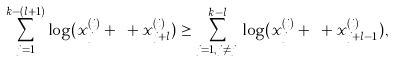Convert formula to latex. <formula><loc_0><loc_0><loc_500><loc_500>\sum _ { j = 1 } ^ { k - ( l + 1 ) } \log ( x ^ { ( i ) } _ { j } + \dots + x ^ { ( i ) } _ { j + l } ) \geq \sum _ { j = 1 , j \not = j _ { l } } ^ { k - l } \log ( x ^ { ( i ) } _ { j } + \dots + x ^ { ( i ) } _ { j + l - 1 } ) ,</formula> 